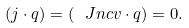Convert formula to latex. <formula><loc_0><loc_0><loc_500><loc_500>( j \cdot q ) = ( \ J n c v \cdot q ) = 0 .</formula> 